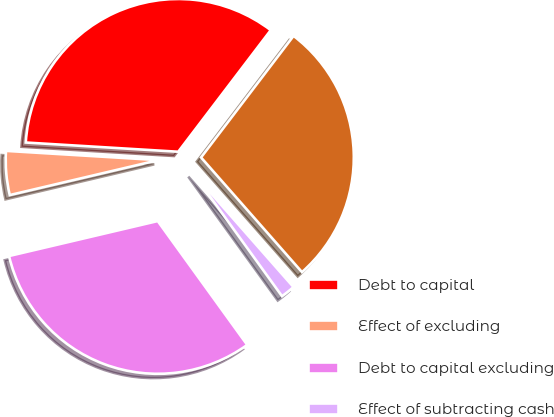<chart> <loc_0><loc_0><loc_500><loc_500><pie_chart><fcel>Debt to capital<fcel>Effect of excluding<fcel>Debt to capital excluding<fcel>Effect of subtracting cash<fcel>Net debt to net capital<nl><fcel>34.39%<fcel>4.64%<fcel>31.28%<fcel>1.53%<fcel>28.16%<nl></chart> 